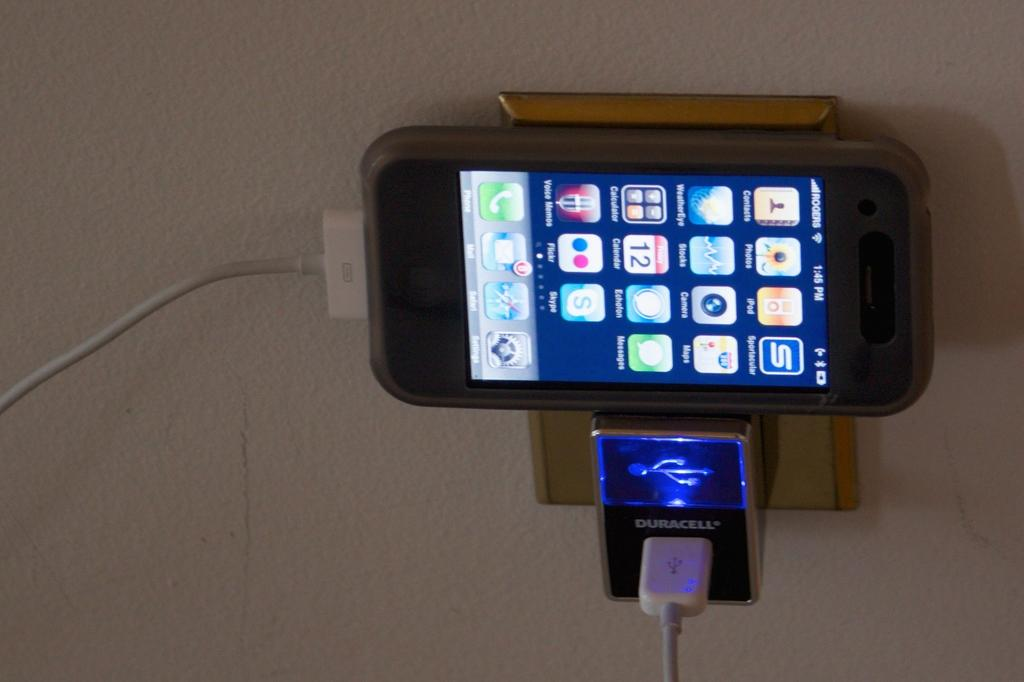<image>
Give a short and clear explanation of the subsequent image. A Duracell phone charger that is plugged into the wall. 